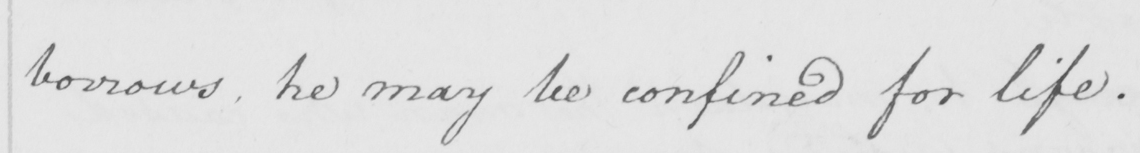Please transcribe the handwritten text in this image. borrows , he may be confined for life . 